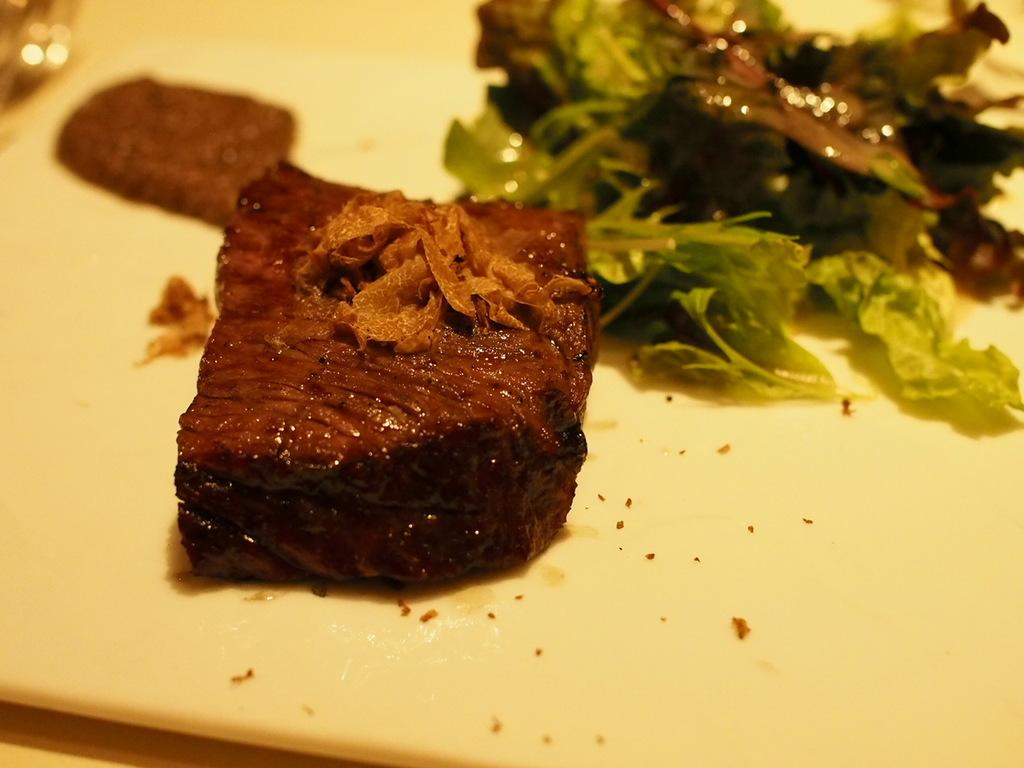What is located in the foreground of the image? There are food items in a plate in the foreground of the image. What type of receipt can be seen next to the food items in the image? There is no receipt present in the image; it only features food items in a plate. How many goats are visible in the image? There are no goats present in the image. 